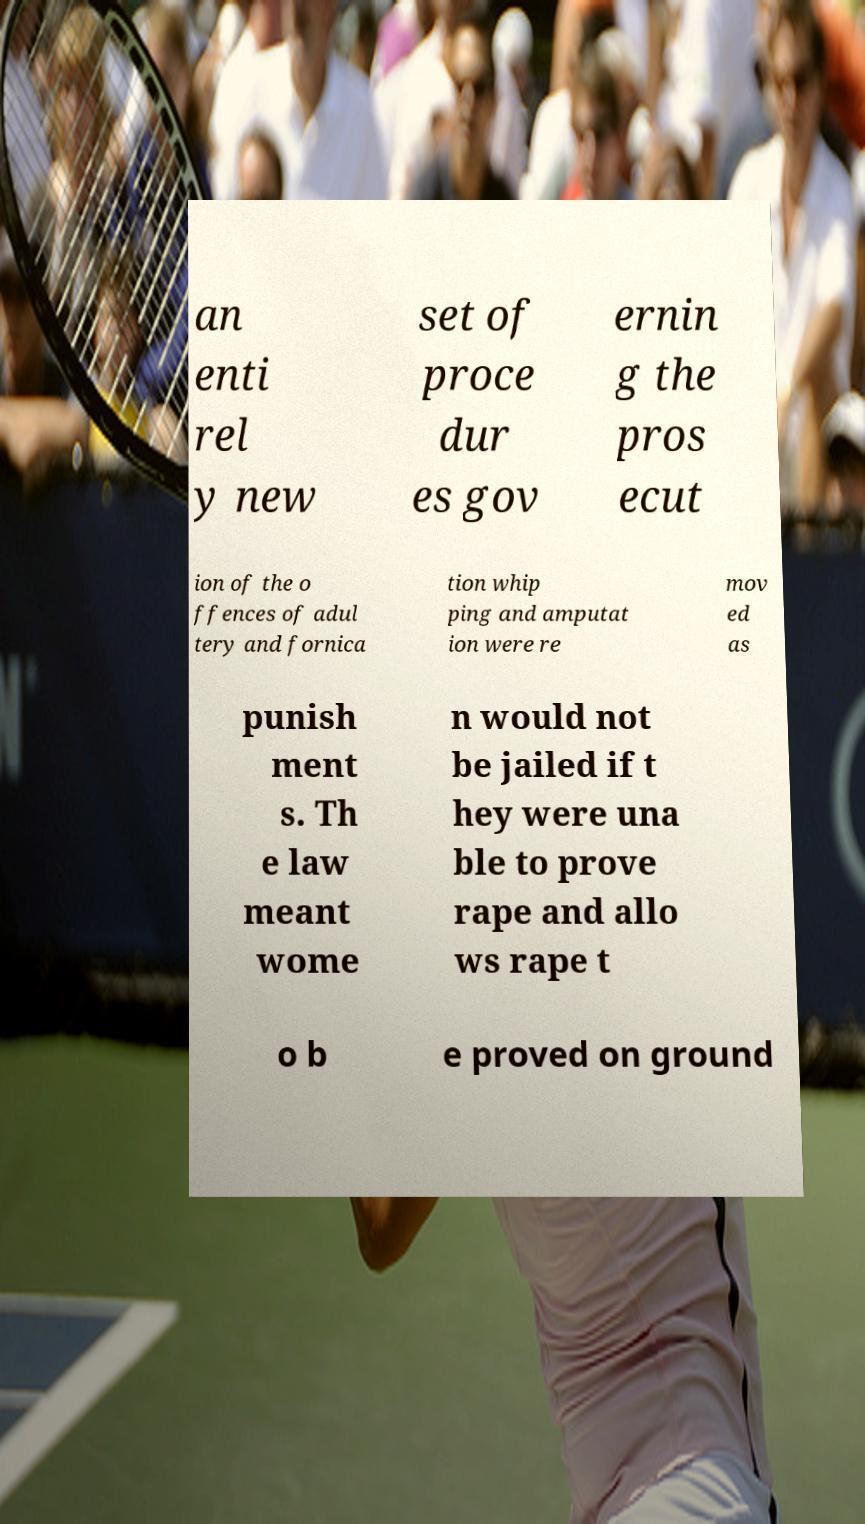Can you read and provide the text displayed in the image?This photo seems to have some interesting text. Can you extract and type it out for me? an enti rel y new set of proce dur es gov ernin g the pros ecut ion of the o ffences of adul tery and fornica tion whip ping and amputat ion were re mov ed as punish ment s. Th e law meant wome n would not be jailed if t hey were una ble to prove rape and allo ws rape t o b e proved on ground 